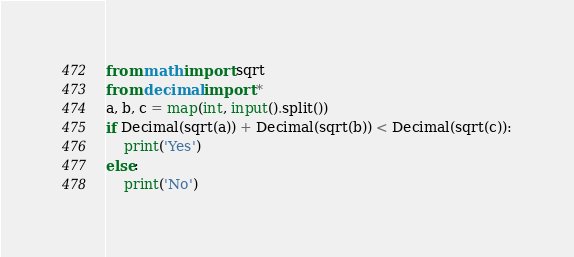Convert code to text. <code><loc_0><loc_0><loc_500><loc_500><_Python_>from math import sqrt
from decimal import *
a, b, c = map(int, input().split())
if Decimal(sqrt(a)) + Decimal(sqrt(b)) < Decimal(sqrt(c)):
    print('Yes')
else:
    print('No')
</code> 